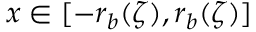<formula> <loc_0><loc_0><loc_500><loc_500>x \in [ - r _ { b } ( \zeta ) , r _ { b } ( \zeta ) ]</formula> 